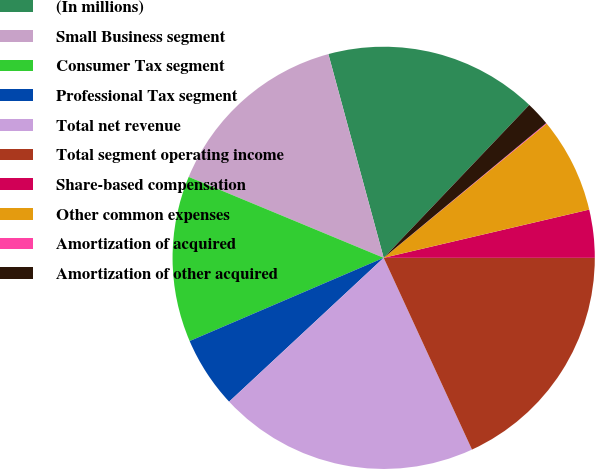Convert chart to OTSL. <chart><loc_0><loc_0><loc_500><loc_500><pie_chart><fcel>(In millions)<fcel>Small Business segment<fcel>Consumer Tax segment<fcel>Professional Tax segment<fcel>Total net revenue<fcel>Total segment operating income<fcel>Share-based compensation<fcel>Other common expenses<fcel>Amortization of acquired<fcel>Amortization of other acquired<nl><fcel>16.33%<fcel>14.52%<fcel>12.71%<fcel>5.48%<fcel>19.94%<fcel>18.13%<fcel>3.67%<fcel>7.29%<fcel>0.06%<fcel>1.87%<nl></chart> 